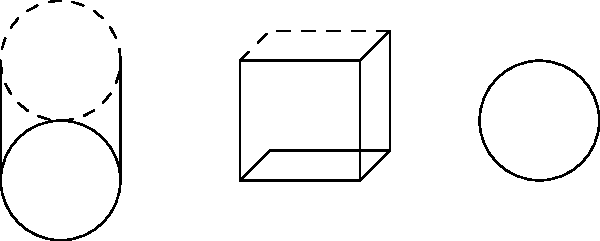As a consultant in the marijuana industry, you need to estimate the volume of different containers used for storing products. Given three containers - a cylinder, a cube, and a sphere - with the dimensions shown in the diagram, which container has the largest volume for storing marijuana products? To determine which container has the largest volume, we need to calculate the volume of each shape:

1. Cylinder:
   Volume = $\pi r^2 h$
   $V_{cylinder} = \pi \cdot 1^2 \cdot 2 = 2\pi \approx 6.28$ cubic units

2. Cube:
   Volume = $s^3$
   $V_{cube} = 2^3 = 8$ cubic units

3. Sphere:
   Volume = $\frac{4}{3}\pi r^3$
   $V_{sphere} = \frac{4}{3}\pi \cdot 1^3 = \frac{4}{3}\pi \approx 4.19$ cubic units

Comparing the volumes:
$V_{cube} > V_{cylinder} > V_{sphere}$

Therefore, the cube has the largest volume for storing marijuana products.
Answer: Cube 